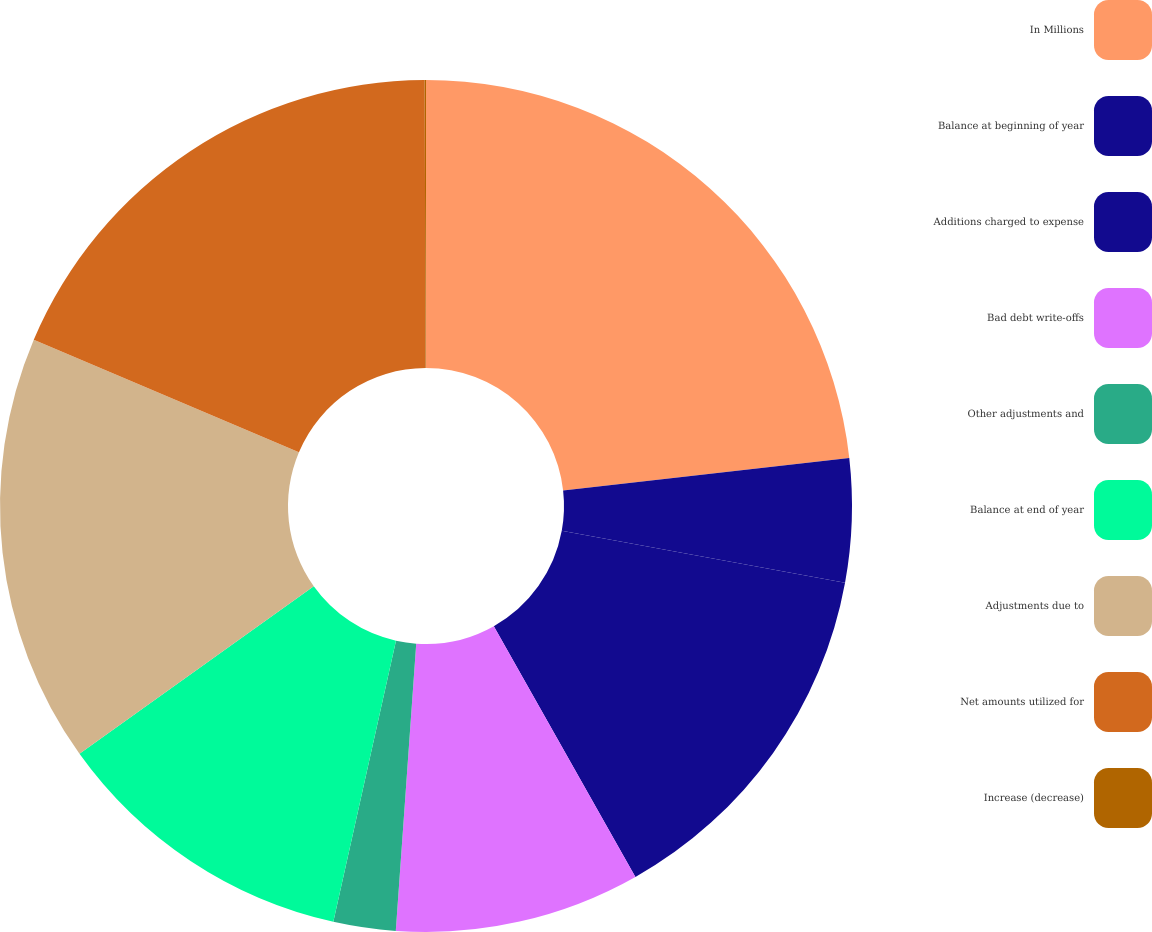<chart> <loc_0><loc_0><loc_500><loc_500><pie_chart><fcel>In Millions<fcel>Balance at beginning of year<fcel>Additions charged to expense<fcel>Bad debt write-offs<fcel>Other adjustments and<fcel>Balance at end of year<fcel>Adjustments due to<fcel>Net amounts utilized for<fcel>Increase (decrease)<nl><fcel>23.2%<fcel>4.68%<fcel>13.94%<fcel>9.31%<fcel>2.36%<fcel>11.63%<fcel>16.26%<fcel>18.57%<fcel>0.05%<nl></chart> 